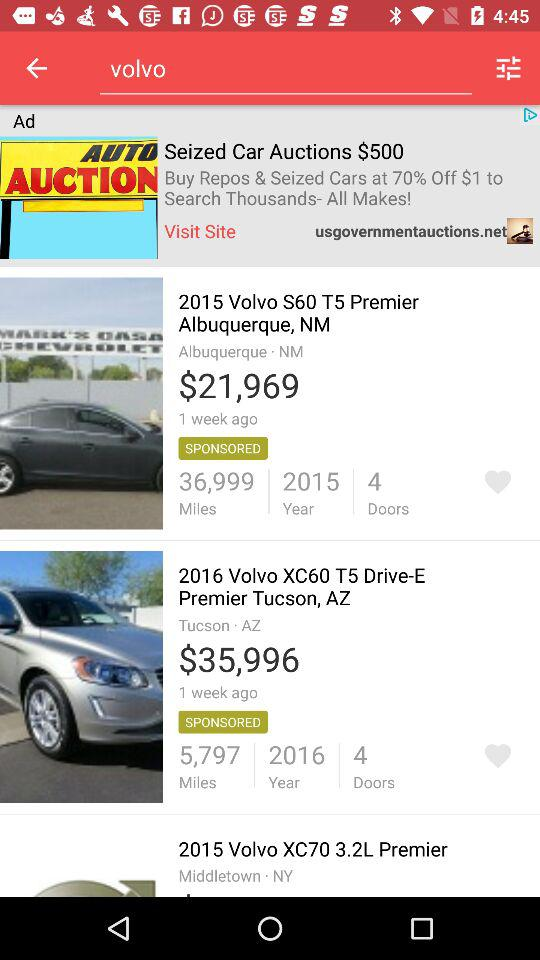How much more expensive is the 2016 Volvo XC60 than the 2015 Volvo S60?
Answer the question using a single word or phrase. $14027 